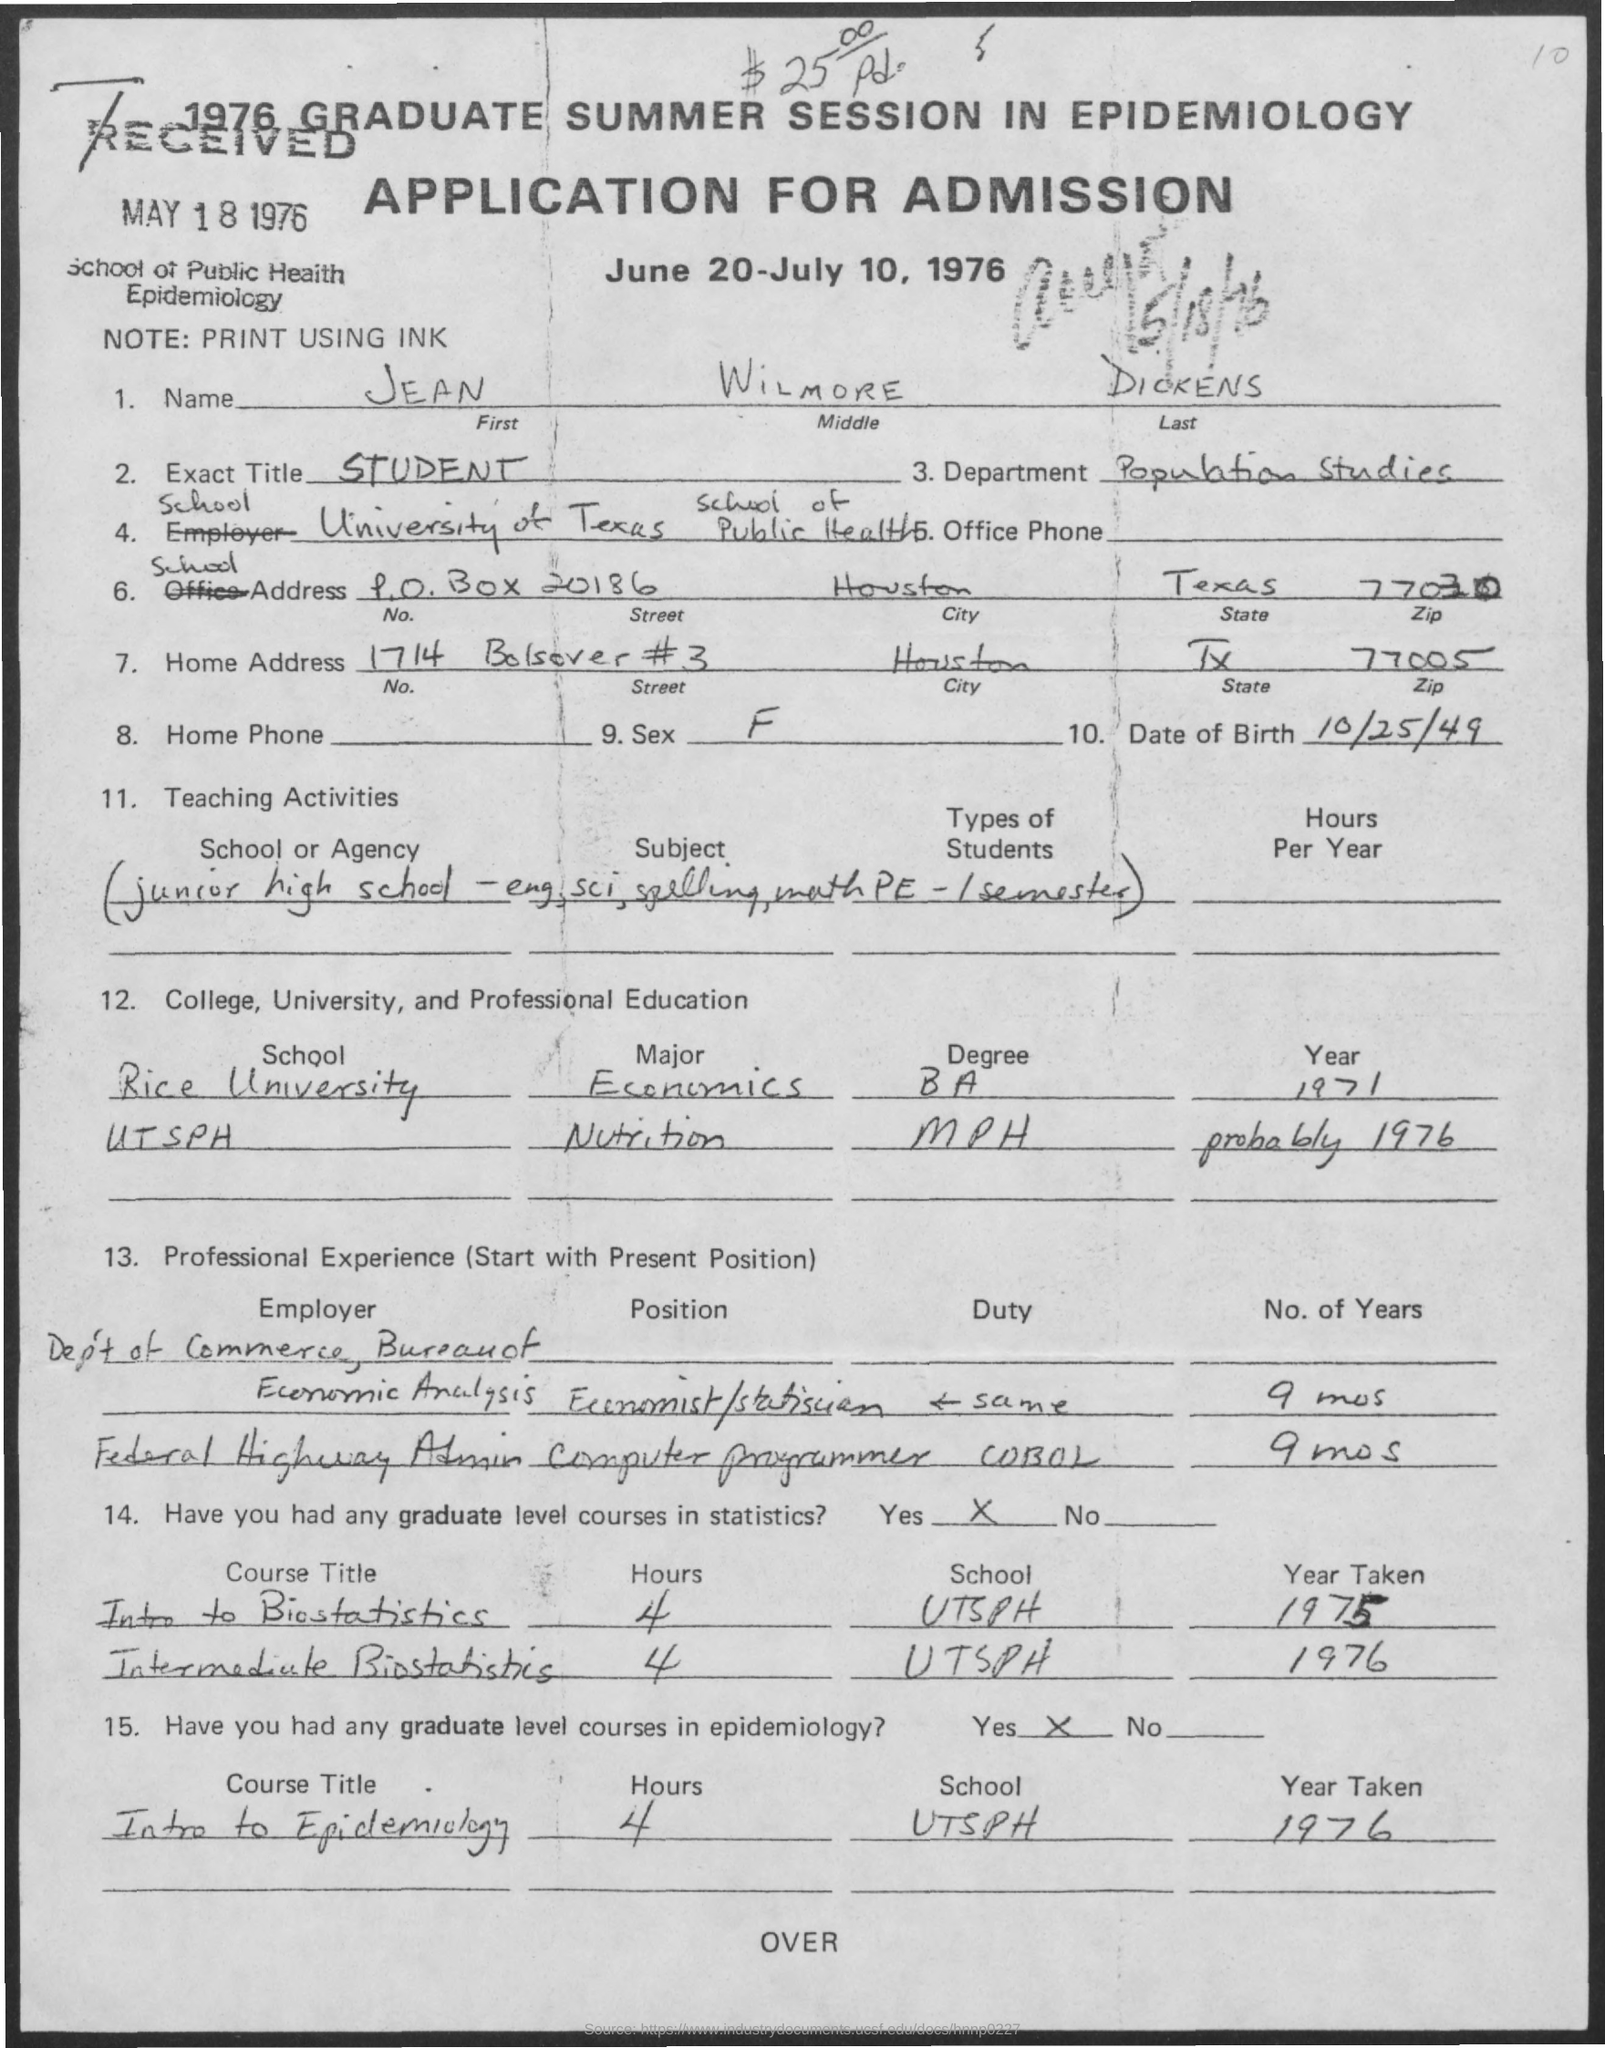Can you tell me the period when this application was open for submissions? The application indicates that it was for the 1976 Graduate Summer Session in Epidemiology, which was open for the period from June 20 to July 10, 1976. 